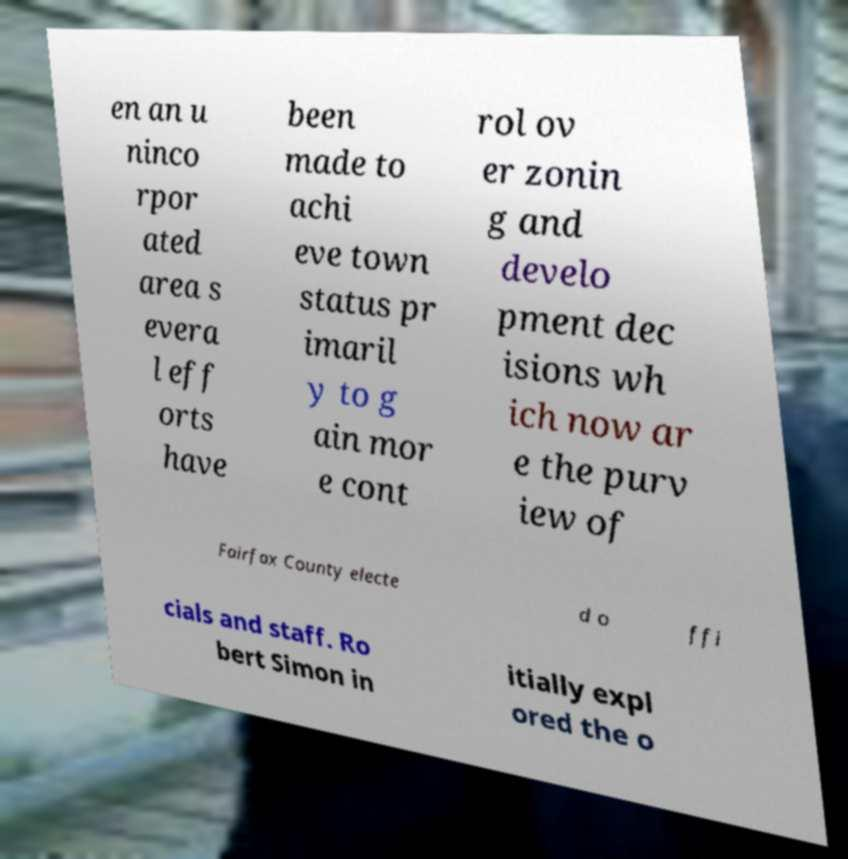Can you accurately transcribe the text from the provided image for me? en an u ninco rpor ated area s evera l eff orts have been made to achi eve town status pr imaril y to g ain mor e cont rol ov er zonin g and develo pment dec isions wh ich now ar e the purv iew of Fairfax County electe d o ffi cials and staff. Ro bert Simon in itially expl ored the o 